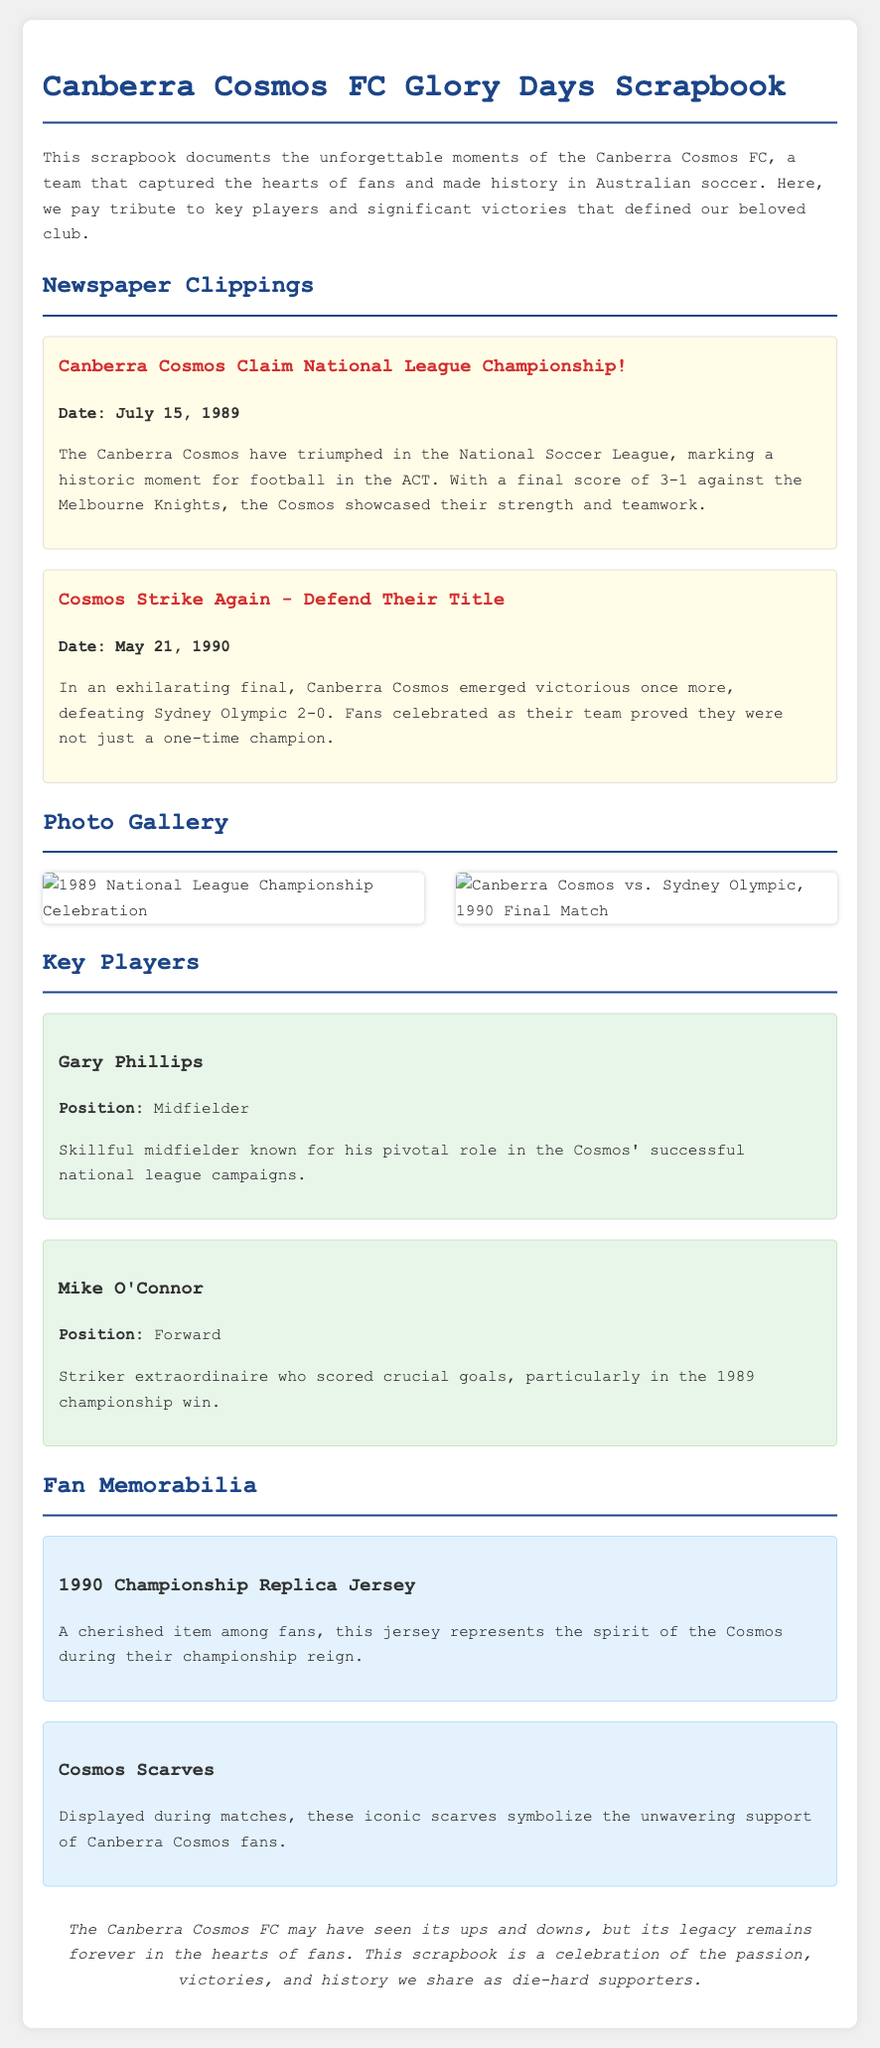What is the title of the scrapbook? The title of the scrapbook is stated at the top of the document, highlighting the focus on the team's history.
Answer: Canberra Cosmos FC Glory Days Scrapbook When did the Canberra Cosmos claim the National League Championship? The date is specified in the newspaper clipping discussing the championship victory.
Answer: July 15, 1989 Who scored crucial goals in the 1989 championship win? This information can be found in the player card description about a key player in that victory.
Answer: Mike O'Connor What was the final score against Sydney Olympic in the May 1990 match? The score is mentioned in the article about the second championship victory of the Cosmos.
Answer: 2-0 Which item represents the spirit of the Cosmos during their championship reign? This item is described under the fan memorabilia section of the scrapbook.
Answer: 1990 Championship Replica Jersey What color is the thematic background of the scrapbook document? The color scheme is indicated through the styling in the document's header and body.
Answer: Light gray How many newspaper clippings are included in the document? This can be determined by counting the distinct newspaper clipping sections.
Answer: Two What position did Gary Phillips play? The position of this key player is stated in his player card section.
Answer: Midfielder What type of item are the iconic scarves mentioned in the memorabilia section? The description in the memorabilia item specifies how the scarves are used and their significance.
Answer: Supporter item 